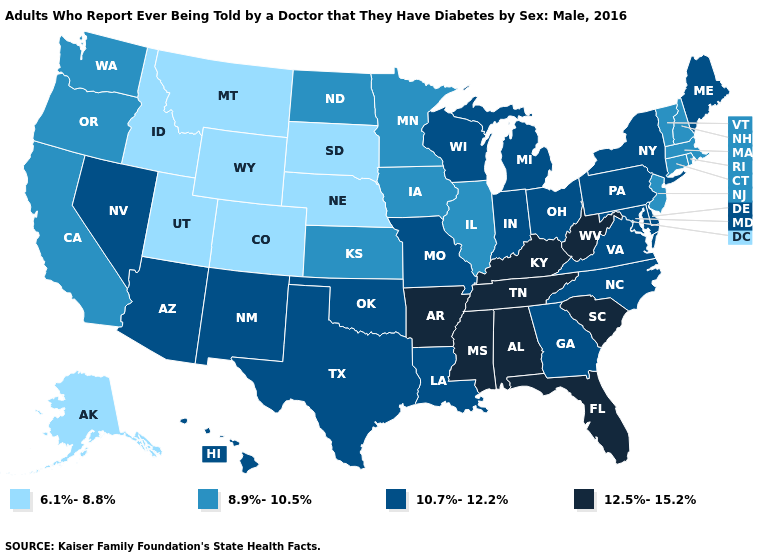What is the highest value in states that border Georgia?
Be succinct. 12.5%-15.2%. Does North Carolina have the highest value in the USA?
Short answer required. No. What is the lowest value in the USA?
Concise answer only. 6.1%-8.8%. Does the map have missing data?
Write a very short answer. No. What is the value of Alabama?
Short answer required. 12.5%-15.2%. Name the states that have a value in the range 8.9%-10.5%?
Be succinct. California, Connecticut, Illinois, Iowa, Kansas, Massachusetts, Minnesota, New Hampshire, New Jersey, North Dakota, Oregon, Rhode Island, Vermont, Washington. Does Colorado have a lower value than Michigan?
Quick response, please. Yes. What is the value of Indiana?
Keep it brief. 10.7%-12.2%. What is the value of Arkansas?
Be succinct. 12.5%-15.2%. Does New Jersey have a lower value than Maine?
Write a very short answer. Yes. Name the states that have a value in the range 6.1%-8.8%?
Give a very brief answer. Alaska, Colorado, Idaho, Montana, Nebraska, South Dakota, Utah, Wyoming. Which states have the highest value in the USA?
Give a very brief answer. Alabama, Arkansas, Florida, Kentucky, Mississippi, South Carolina, Tennessee, West Virginia. Does the map have missing data?
Concise answer only. No. Does the map have missing data?
Concise answer only. No. What is the highest value in the USA?
Short answer required. 12.5%-15.2%. 